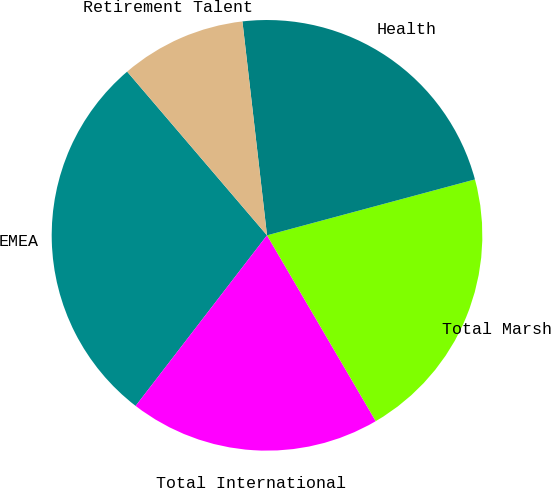Convert chart. <chart><loc_0><loc_0><loc_500><loc_500><pie_chart><fcel>EMEA<fcel>Total International<fcel>Total Marsh<fcel>Health<fcel>Retirement Talent<nl><fcel>28.3%<fcel>18.87%<fcel>20.75%<fcel>22.64%<fcel>9.43%<nl></chart> 